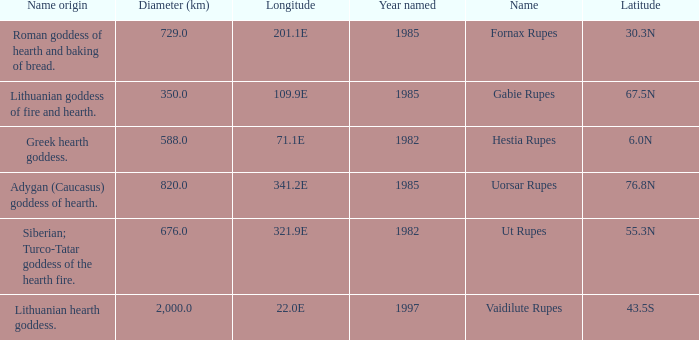What was the diameter of the feature found in 1997? 2000.0. 